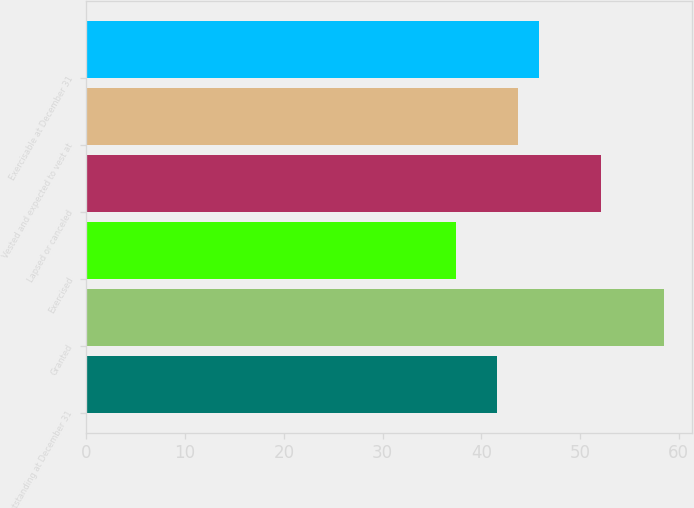Convert chart to OTSL. <chart><loc_0><loc_0><loc_500><loc_500><bar_chart><fcel>Outstanding at December 31<fcel>Granted<fcel>Exercised<fcel>Lapsed or canceled<fcel>Vested and expected to vest at<fcel>Exercisable at December 31<nl><fcel>41.62<fcel>58.46<fcel>37.4<fcel>52.17<fcel>43.73<fcel>45.84<nl></chart> 